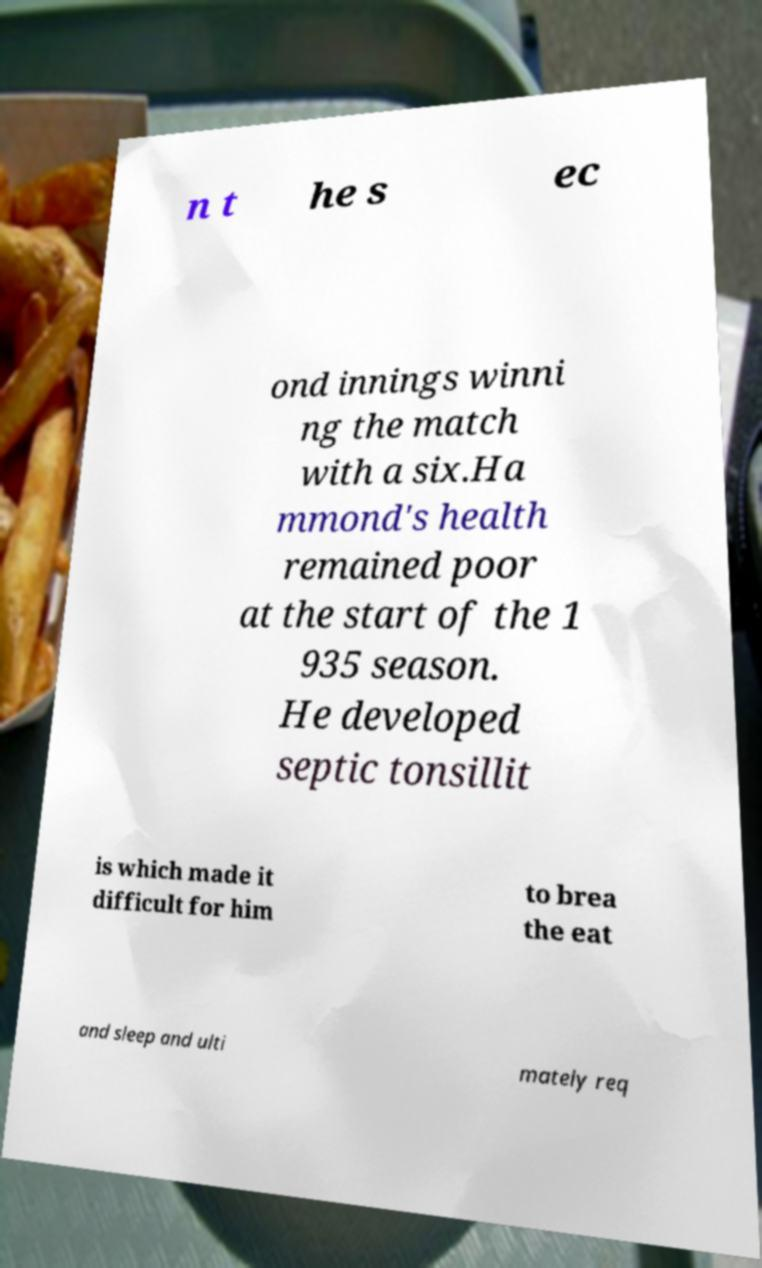Could you extract and type out the text from this image? n t he s ec ond innings winni ng the match with a six.Ha mmond's health remained poor at the start of the 1 935 season. He developed septic tonsillit is which made it difficult for him to brea the eat and sleep and ulti mately req 